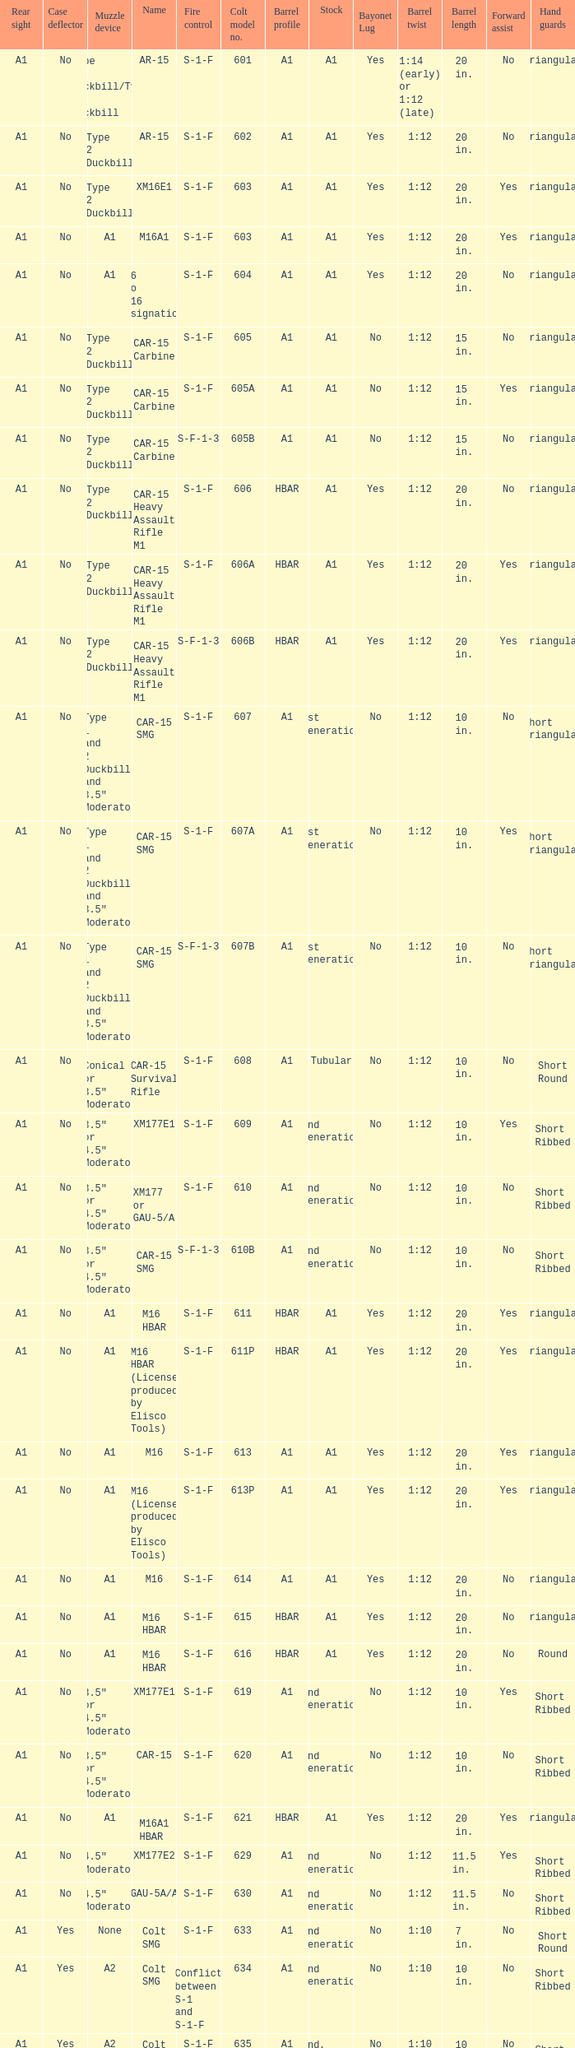What is the rear sight in the Cole model no. 735? A1 or A2. 